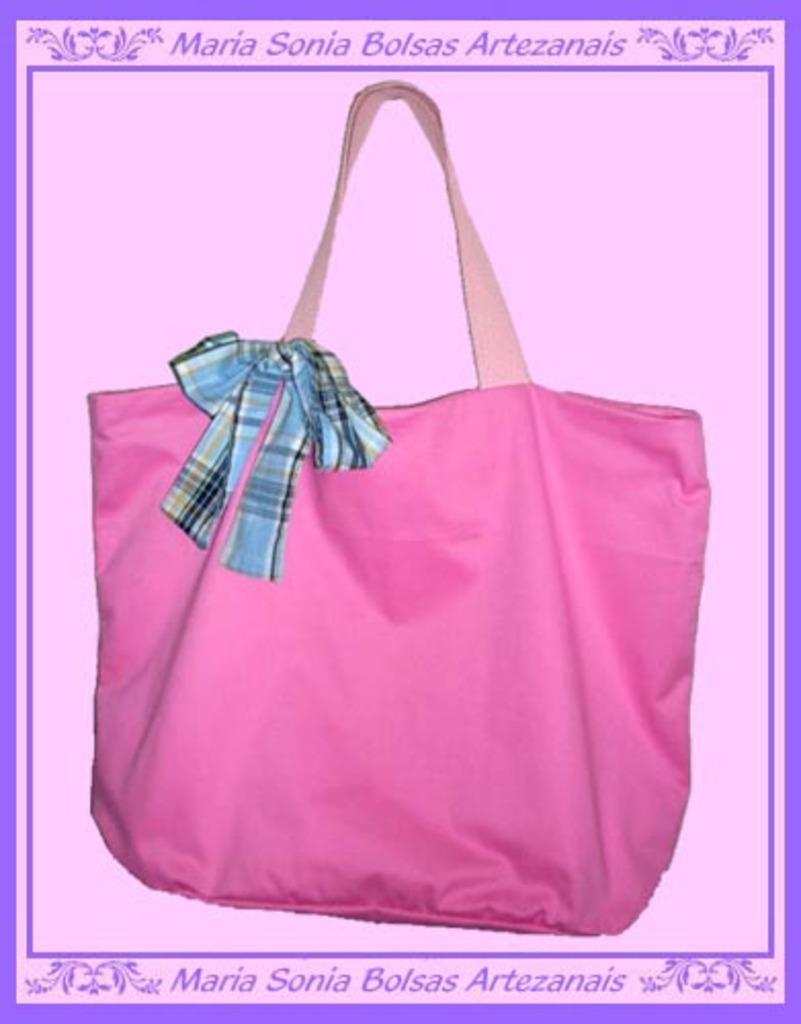What is the main subject of the poster in the image? The poster features a bag. Is there any additional detail about the bag? Yes, there is cloth attached to the bag. What else can be seen on the poster besides the bag? There is text written on the poster. What type of trouble is the vase causing in the image? There is no vase present in the image, so it cannot be causing any trouble. 